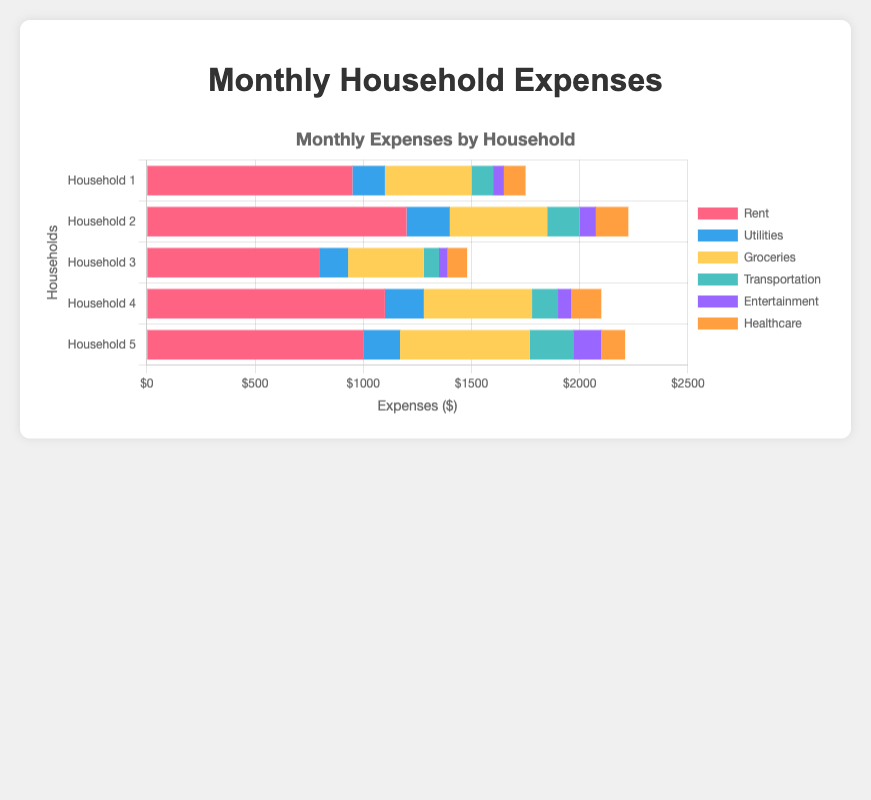What is the total monthly expense for Household 3? The total monthly expense for Household 3 is the sum of all its expenses: Rent ($800) + Utilities ($130) + Groceries ($350) + Transportation ($70) + Entertainment ($40) + Healthcare ($90). Adding these up gives $1480.
Answer: $1480 Which household spends the most on Groceries? By comparing the Groceries segment in the horizontal bars, Household 5 spends the most on Groceries with an amount of $600, as the yellow section representing Groceries is the longest for Household 5.
Answer: Household 5 Which household has the lowest rent? Comparing the length of the red sections for each household, Household 3 has the lowest rent at $800, as it has the shortest red segment.
Answer: Household 3 What is the difference in Transportation expenses between Household 2 and Household 5? Household 2 spends $150 on Transportation, while Household 5 spends $200. The difference in Transportation expenses is $200 - $150 = $50.
Answer: $50 Which household spends the least on Entertainment? By looking at the purple sections in the horizontal bars, Household 3 spends the least on Entertainment at $40, as it has the shortest purple segment.
Answer: Household 3 What is the average spending on Healthcare for all households? The Healthcare spending amounts are $100, $150, $90, $140, and $110. Adding these, we get $100 + $150 + $90 + $140 + $110 = $590. Dividing by the number of households (5), the average is $590 / 5 = $118.
Answer: $118 Do any two households have the same total expenses for Entertainment and Transportation combined? Adding Entertainment and Transportation for each household gives: Household 1: $50 + $100 = $150, Household 2: $75 + $150 = $225, Household 3: $40 + $70 = $110, Household 4: $60 + $120 = $180, Household 5: $130 + $200 = $330. No two households have the same total for these categories.
Answer: No Which household has the highest total expenses? Adding the total expenses for each household, Household 5 has the highest with a total of $2210 ($1000 for Rent, $170 for Utilities, $600 for Groceries, $200 for Transportation, $130 for Entertainment, $110 for Healthcare). The visual check confirms this bar is the longest.
Answer: Household 5 How much more does Household 4 spend on Rent compared to Household 3? Household 4 spends $1100 on Rent, while Household 3 spends $800. The difference is $1100 - $800 = $300.
Answer: $300 